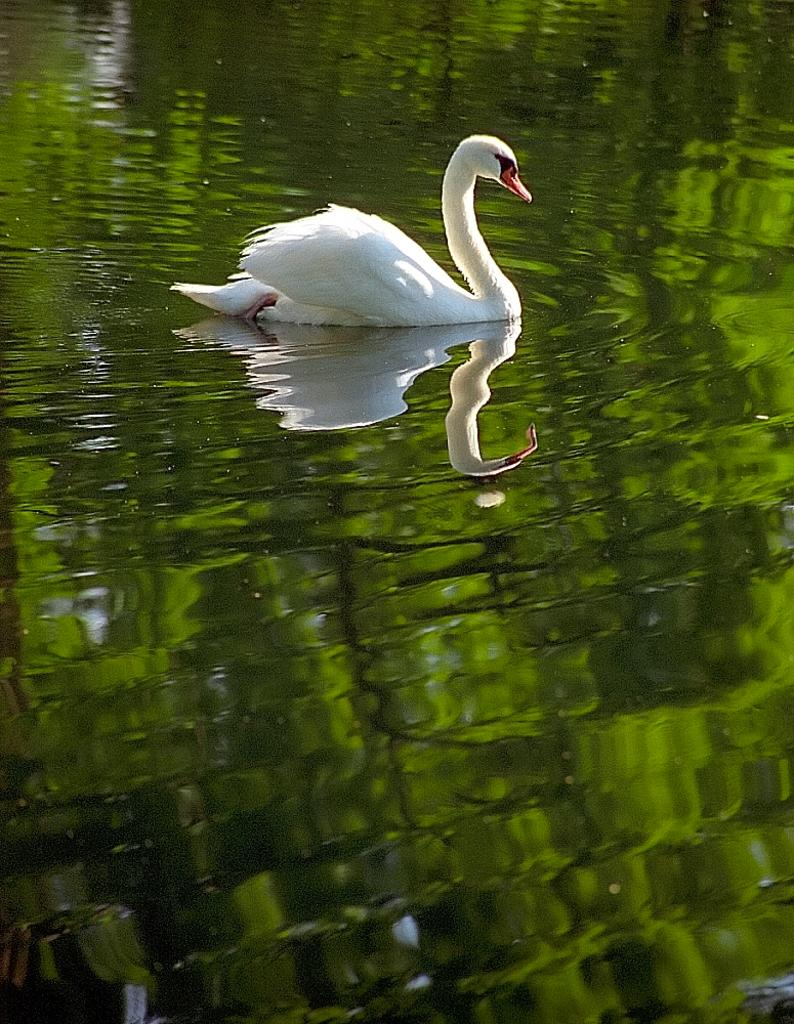What animal is present in the image? There is a swan in the image. Where is the swan located? The swan is on the water. What can be observed about the swan's reflection in the water? The reflection of the swan is visible on the water. What type of pancake is being served at the building in the image? There is no building or pancake present in the image; it features a swan on the water. Can you tell me how many bottles of soda are visible in the image? There are no bottles of soda present in the image. 